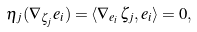Convert formula to latex. <formula><loc_0><loc_0><loc_500><loc_500>\eta _ { j } ( \nabla _ { \zeta _ { j } } e _ { i } ) = \langle \nabla _ { e _ { i } } \zeta _ { j } , e _ { i } \rangle = 0 ,</formula> 